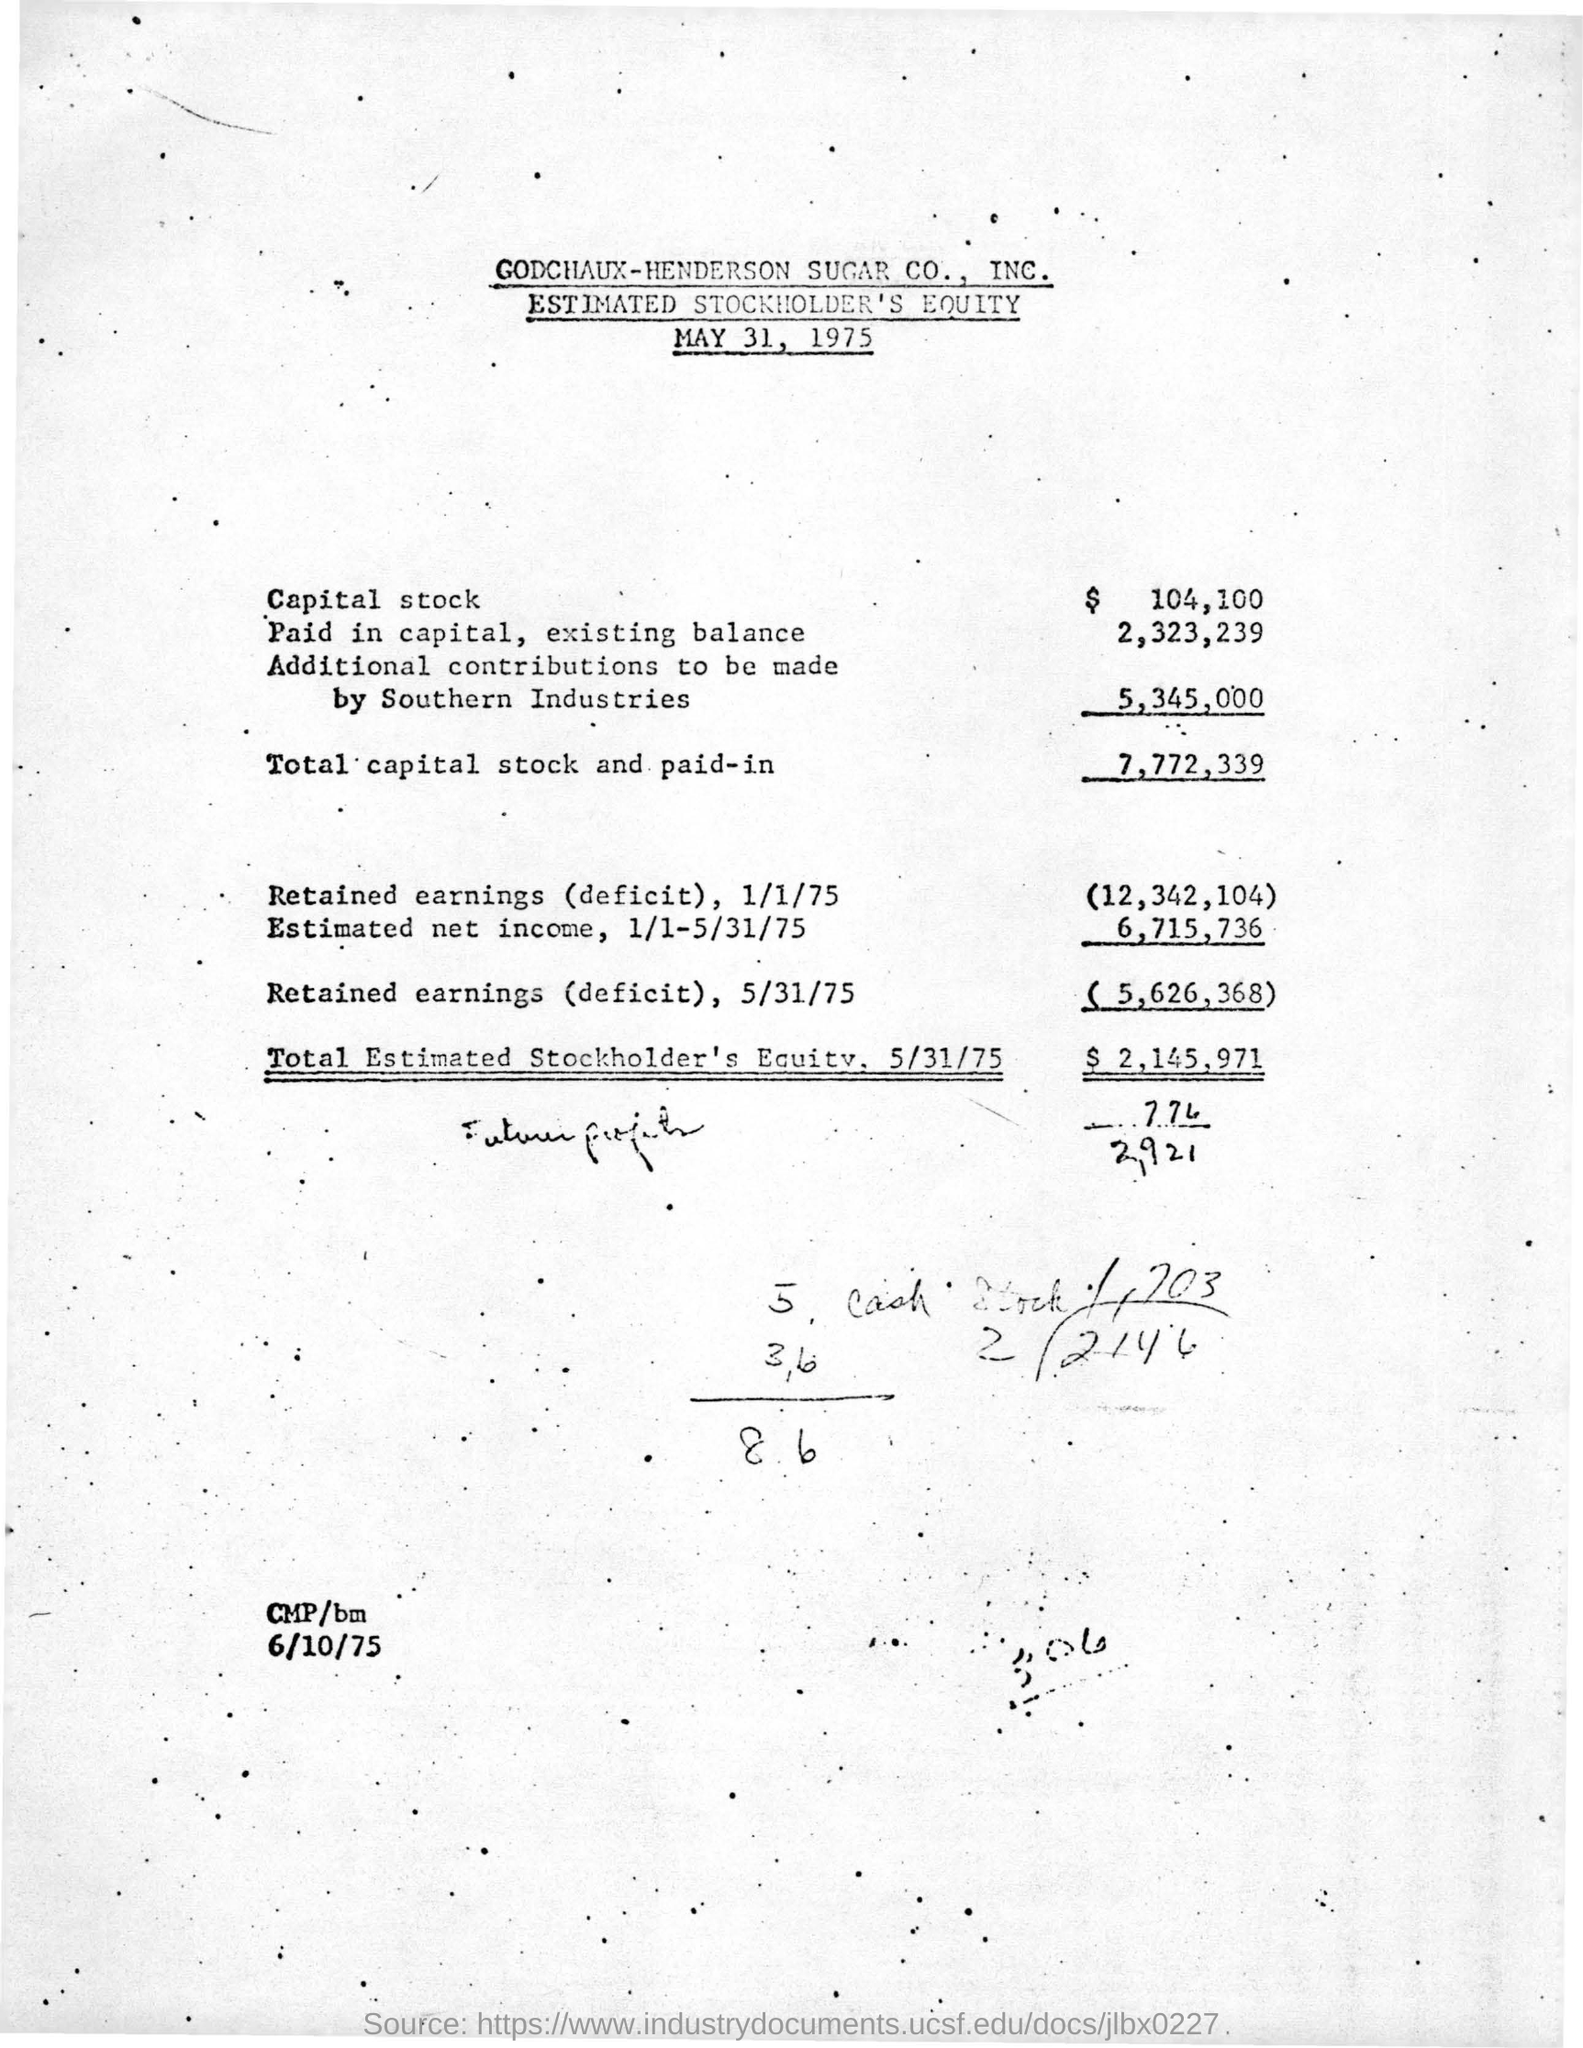What is the total estimated stockholder's equity as on 5/31/75?
Ensure brevity in your answer.  $ 2,145,971. What is the date mentioned at the bottom?
Keep it short and to the point. 6/10/75. How much is the Total capital stock and paid-in ?
Ensure brevity in your answer.  7,772,339. What is the date mentioned at the top?
Offer a very short reply. May 31, 1975. 